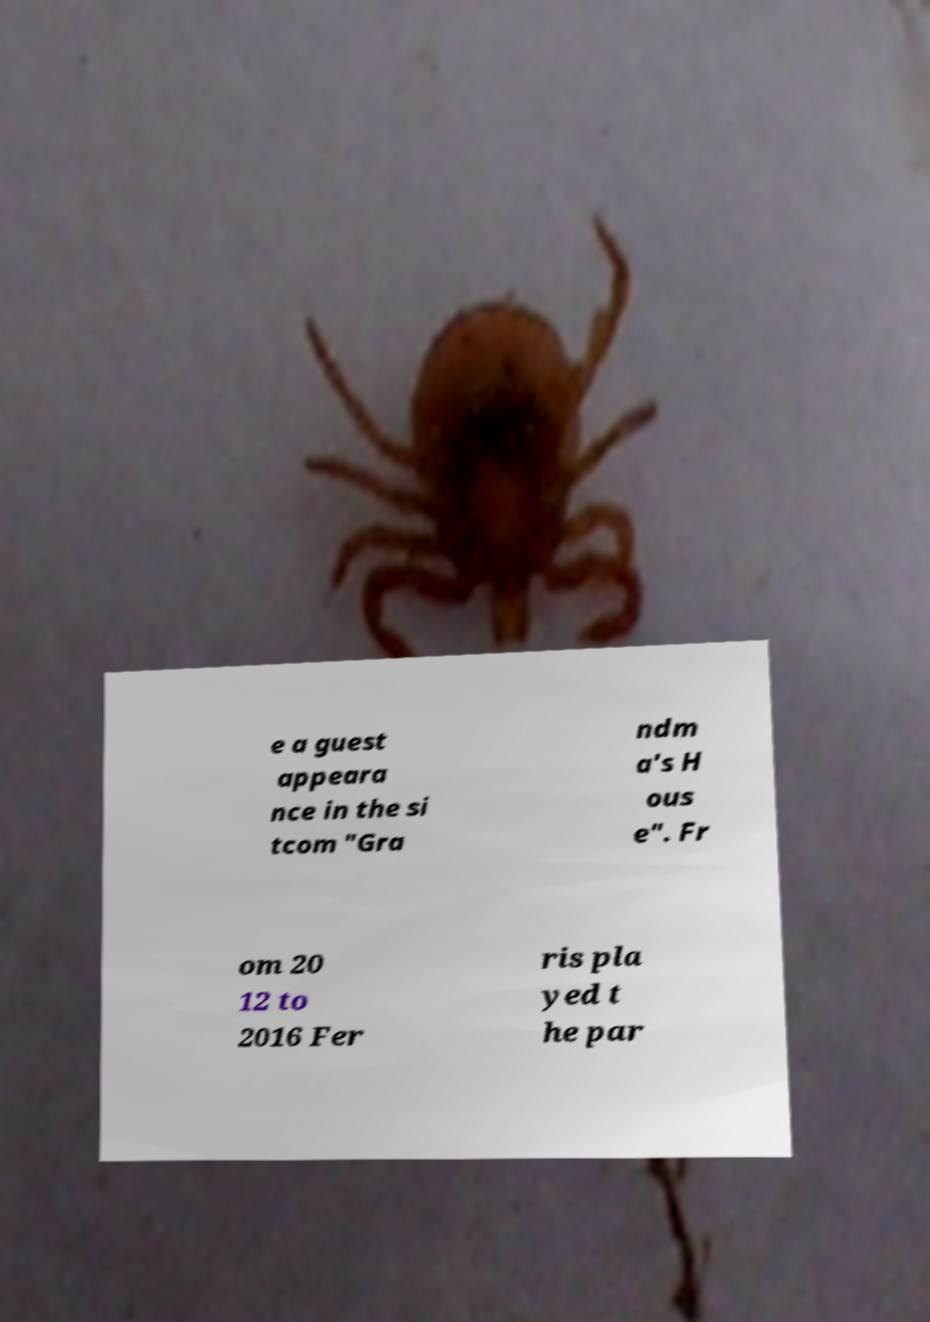There's text embedded in this image that I need extracted. Can you transcribe it verbatim? e a guest appeara nce in the si tcom "Gra ndm a's H ous e". Fr om 20 12 to 2016 Fer ris pla yed t he par 